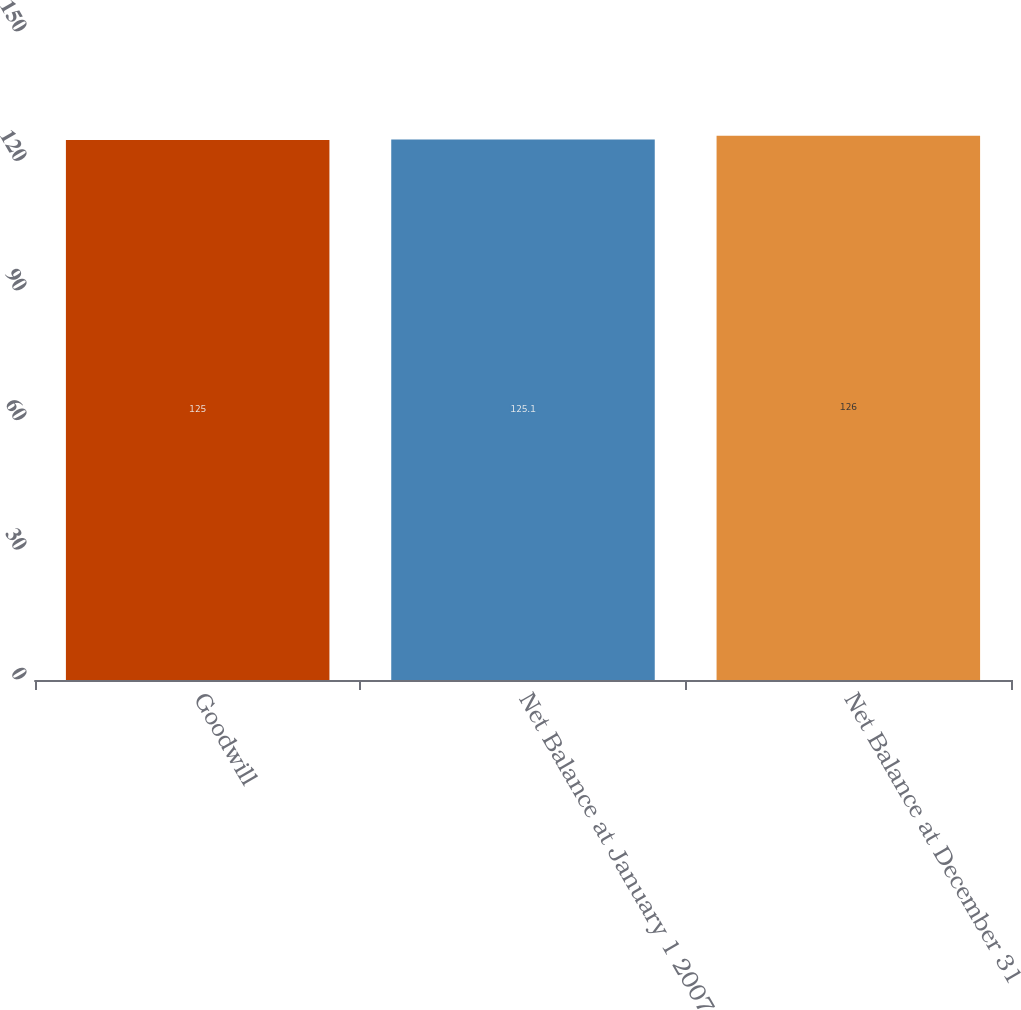Convert chart to OTSL. <chart><loc_0><loc_0><loc_500><loc_500><bar_chart><fcel>Goodwill<fcel>Net Balance at January 1 2007<fcel>Net Balance at December 31<nl><fcel>125<fcel>125.1<fcel>126<nl></chart> 